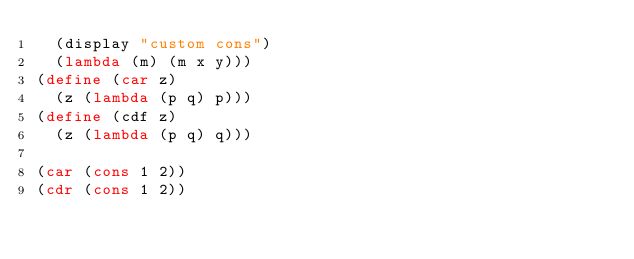Convert code to text. <code><loc_0><loc_0><loc_500><loc_500><_Scheme_>  (display "custom cons")
  (lambda (m) (m x y)))
(define (car z)
  (z (lambda (p q) p)))
(define (cdf z)
  (z (lambda (p q) q)))

(car (cons 1 2))
(cdr (cons 1 2))</code> 